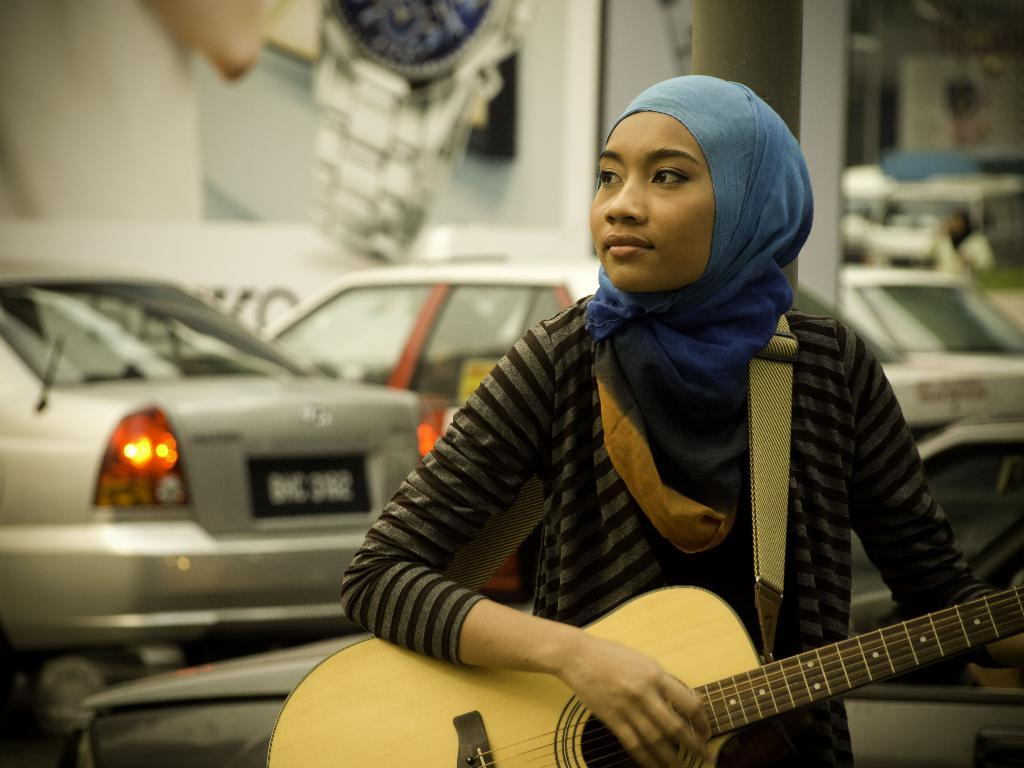What is the main subject of the image? There is a person in the image. What is the person holding in the image? The person is holding a guitar. What can be seen in the background of the image? There are cars in the background of the image. What type of advertisement can be seen on the guitar in the image? There is no advertisement present on the guitar in the image. Where is the room located in the image? The image does not depict a room; it shows a person holding a guitar with cars in the background. 